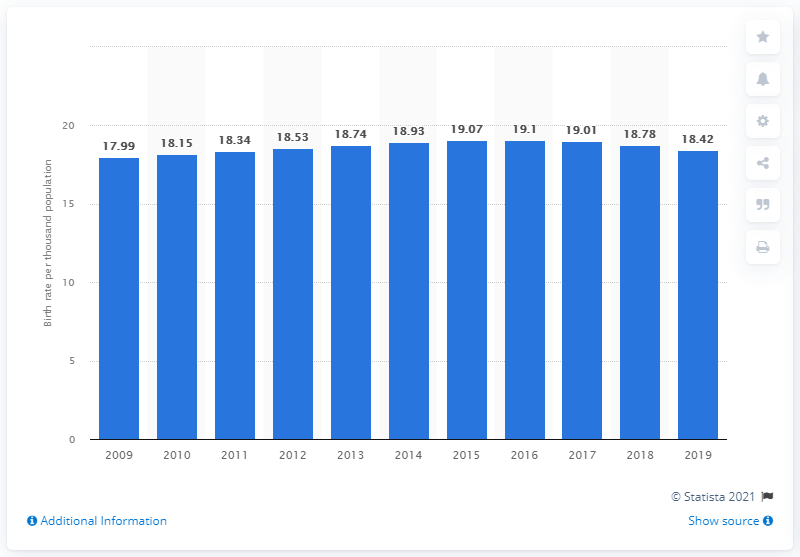Highlight a few significant elements in this photo. In 2019, Iran's crude birth rate was 18.42. 